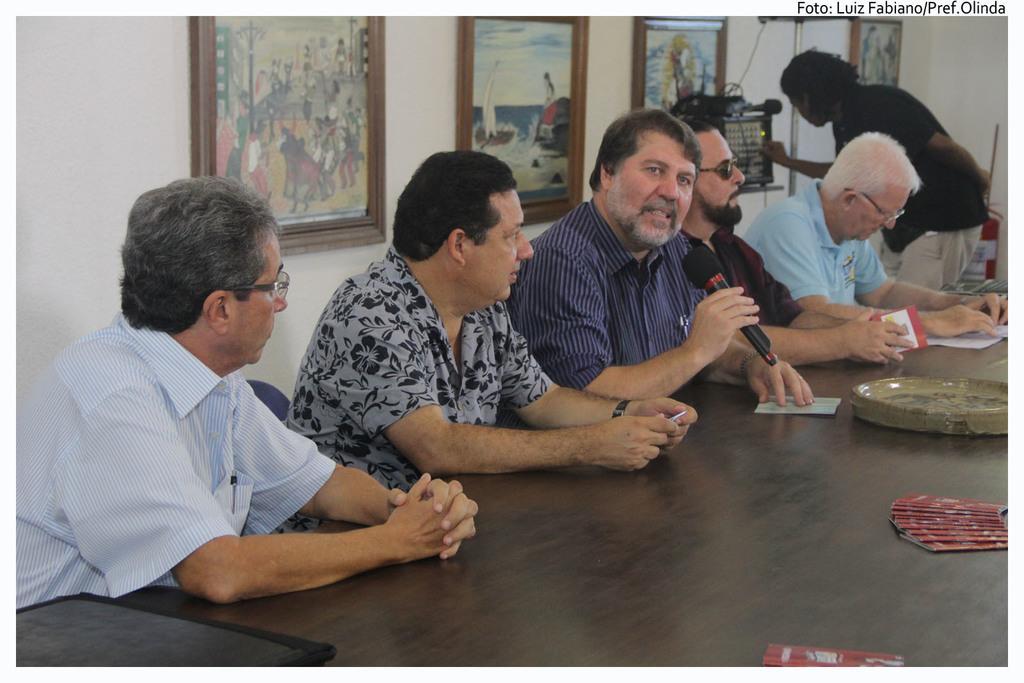Describe this image in one or two sentences. In this image I can see the group of people with different color dresses. I can see one person standing and holding an electronic gadget. I can see one person holding the mic and there are some objects on the table. In the background I can see some frames to the wall. 